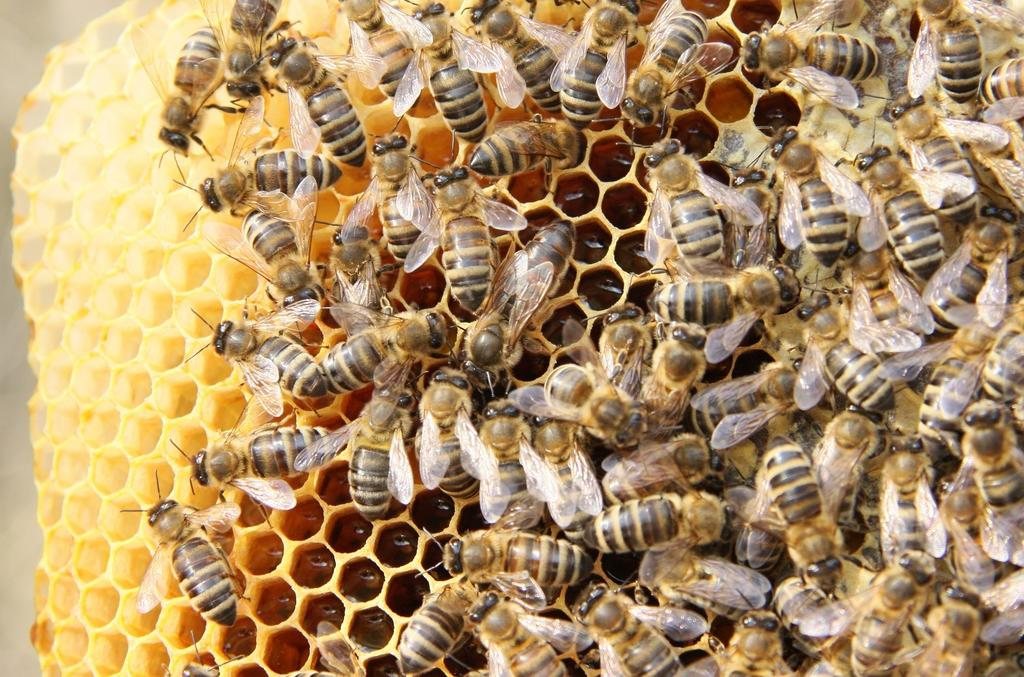What type of insects are present in the image? There are honey bees in the image. What structure are the honey bees on? The honey bees are on a honeycomb. Can you see a kitten playing with a twig on the honeycomb in the image? There is no kitten or twig present in the image; it only features honey bees on a honeycomb. Are there any cattle visible in the image? There are no cattle present in the image. 